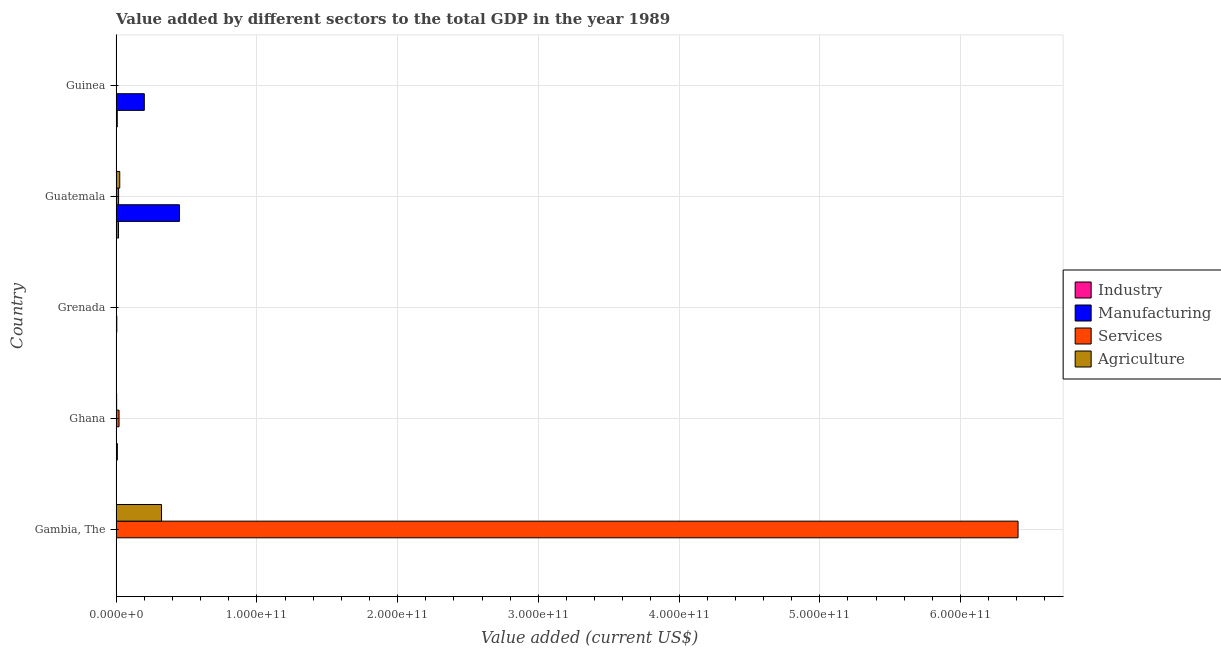How many different coloured bars are there?
Offer a terse response. 4. How many groups of bars are there?
Keep it short and to the point. 5. Are the number of bars on each tick of the Y-axis equal?
Your answer should be compact. Yes. How many bars are there on the 1st tick from the top?
Offer a very short reply. 4. How many bars are there on the 5th tick from the bottom?
Your answer should be compact. 4. What is the label of the 2nd group of bars from the top?
Your response must be concise. Guatemala. What is the value added by industrial sector in Ghana?
Offer a terse response. 8.78e+08. Across all countries, what is the maximum value added by manufacturing sector?
Provide a short and direct response. 4.50e+1. Across all countries, what is the minimum value added by agricultural sector?
Your answer should be very brief. 2.63e+07. In which country was the value added by services sector maximum?
Your answer should be very brief. Gambia, The. In which country was the value added by services sector minimum?
Offer a very short reply. Guinea. What is the total value added by manufacturing sector in the graph?
Make the answer very short. 6.55e+1. What is the difference between the value added by manufacturing sector in Ghana and that in Guatemala?
Your answer should be very brief. -4.49e+1. What is the difference between the value added by agricultural sector in Grenada and the value added by manufacturing sector in Ghana?
Offer a terse response. 2.91e+07. What is the average value added by manufacturing sector per country?
Provide a short and direct response. 1.31e+1. What is the difference between the value added by industrial sector and value added by services sector in Gambia, The?
Provide a succinct answer. -6.41e+11. What is the ratio of the value added by industrial sector in Ghana to that in Grenada?
Offer a very short reply. 28.63. Is the value added by industrial sector in Gambia, The less than that in Ghana?
Your answer should be very brief. Yes. What is the difference between the highest and the second highest value added by services sector?
Provide a succinct answer. 6.39e+11. What is the difference between the highest and the lowest value added by industrial sector?
Your answer should be very brief. 1.66e+09. Is the sum of the value added by services sector in Gambia, The and Guatemala greater than the maximum value added by agricultural sector across all countries?
Offer a very short reply. Yes. Is it the case that in every country, the sum of the value added by industrial sector and value added by services sector is greater than the sum of value added by manufacturing sector and value added by agricultural sector?
Provide a succinct answer. No. What does the 2nd bar from the top in Guinea represents?
Provide a short and direct response. Services. What does the 3rd bar from the bottom in Gambia, The represents?
Ensure brevity in your answer.  Services. Is it the case that in every country, the sum of the value added by industrial sector and value added by manufacturing sector is greater than the value added by services sector?
Keep it short and to the point. No. Are all the bars in the graph horizontal?
Your answer should be compact. Yes. What is the difference between two consecutive major ticks on the X-axis?
Make the answer very short. 1.00e+11. Are the values on the major ticks of X-axis written in scientific E-notation?
Your answer should be compact. Yes. Does the graph contain any zero values?
Offer a very short reply. No. Does the graph contain grids?
Your answer should be compact. Yes. Where does the legend appear in the graph?
Make the answer very short. Center right. How many legend labels are there?
Keep it short and to the point. 4. What is the title of the graph?
Your response must be concise. Value added by different sectors to the total GDP in the year 1989. Does "Miscellaneous expenses" appear as one of the legend labels in the graph?
Ensure brevity in your answer.  No. What is the label or title of the X-axis?
Ensure brevity in your answer.  Value added (current US$). What is the label or title of the Y-axis?
Offer a terse response. Country. What is the Value added (current US$) of Industry in Gambia, The?
Provide a succinct answer. 2.94e+07. What is the Value added (current US$) of Manufacturing in Gambia, The?
Provide a short and direct response. 1.57e+07. What is the Value added (current US$) of Services in Gambia, The?
Your answer should be very brief. 6.41e+11. What is the Value added (current US$) of Agriculture in Gambia, The?
Your response must be concise. 3.23e+1. What is the Value added (current US$) of Industry in Ghana?
Give a very brief answer. 8.78e+08. What is the Value added (current US$) in Manufacturing in Ghana?
Offer a very short reply. 4.45e+07. What is the Value added (current US$) in Services in Ghana?
Your response must be concise. 2.08e+09. What is the Value added (current US$) in Agriculture in Ghana?
Provide a short and direct response. 3.64e+08. What is the Value added (current US$) in Industry in Grenada?
Give a very brief answer. 3.07e+07. What is the Value added (current US$) of Manufacturing in Grenada?
Offer a terse response. 4.79e+08. What is the Value added (current US$) in Services in Grenada?
Ensure brevity in your answer.  1.81e+08. What is the Value added (current US$) of Agriculture in Grenada?
Provide a short and direct response. 7.36e+07. What is the Value added (current US$) in Industry in Guatemala?
Provide a short and direct response. 1.69e+09. What is the Value added (current US$) in Manufacturing in Guatemala?
Your answer should be very brief. 4.50e+1. What is the Value added (current US$) in Services in Guatemala?
Make the answer very short. 1.75e+09. What is the Value added (current US$) of Agriculture in Guatemala?
Your response must be concise. 2.57e+09. What is the Value added (current US$) in Industry in Guinea?
Make the answer very short. 8.07e+08. What is the Value added (current US$) in Manufacturing in Guinea?
Provide a short and direct response. 2.00e+1. What is the Value added (current US$) of Services in Guinea?
Offer a very short reply. 1.13e+08. What is the Value added (current US$) of Agriculture in Guinea?
Provide a short and direct response. 2.63e+07. Across all countries, what is the maximum Value added (current US$) in Industry?
Offer a very short reply. 1.69e+09. Across all countries, what is the maximum Value added (current US$) in Manufacturing?
Provide a short and direct response. 4.50e+1. Across all countries, what is the maximum Value added (current US$) in Services?
Offer a terse response. 6.41e+11. Across all countries, what is the maximum Value added (current US$) in Agriculture?
Offer a very short reply. 3.23e+1. Across all countries, what is the minimum Value added (current US$) of Industry?
Offer a terse response. 2.94e+07. Across all countries, what is the minimum Value added (current US$) of Manufacturing?
Offer a very short reply. 1.57e+07. Across all countries, what is the minimum Value added (current US$) in Services?
Give a very brief answer. 1.13e+08. Across all countries, what is the minimum Value added (current US$) of Agriculture?
Provide a short and direct response. 2.63e+07. What is the total Value added (current US$) of Industry in the graph?
Make the answer very short. 3.44e+09. What is the total Value added (current US$) in Manufacturing in the graph?
Provide a short and direct response. 6.55e+1. What is the total Value added (current US$) of Services in the graph?
Offer a very short reply. 6.45e+11. What is the total Value added (current US$) in Agriculture in the graph?
Your answer should be compact. 3.53e+1. What is the difference between the Value added (current US$) in Industry in Gambia, The and that in Ghana?
Your response must be concise. -8.49e+08. What is the difference between the Value added (current US$) in Manufacturing in Gambia, The and that in Ghana?
Provide a succinct answer. -2.88e+07. What is the difference between the Value added (current US$) in Services in Gambia, The and that in Ghana?
Your answer should be very brief. 6.39e+11. What is the difference between the Value added (current US$) of Agriculture in Gambia, The and that in Ghana?
Your response must be concise. 3.19e+1. What is the difference between the Value added (current US$) in Industry in Gambia, The and that in Grenada?
Provide a short and direct response. -1.27e+06. What is the difference between the Value added (current US$) in Manufacturing in Gambia, The and that in Grenada?
Offer a terse response. -4.63e+08. What is the difference between the Value added (current US$) of Services in Gambia, The and that in Grenada?
Offer a very short reply. 6.41e+11. What is the difference between the Value added (current US$) in Agriculture in Gambia, The and that in Grenada?
Your answer should be very brief. 3.22e+1. What is the difference between the Value added (current US$) of Industry in Gambia, The and that in Guatemala?
Provide a succinct answer. -1.66e+09. What is the difference between the Value added (current US$) in Manufacturing in Gambia, The and that in Guatemala?
Your answer should be compact. -4.50e+1. What is the difference between the Value added (current US$) in Services in Gambia, The and that in Guatemala?
Your response must be concise. 6.39e+11. What is the difference between the Value added (current US$) of Agriculture in Gambia, The and that in Guatemala?
Keep it short and to the point. 2.97e+1. What is the difference between the Value added (current US$) in Industry in Gambia, The and that in Guinea?
Your answer should be compact. -7.78e+08. What is the difference between the Value added (current US$) of Manufacturing in Gambia, The and that in Guinea?
Offer a very short reply. -2.00e+1. What is the difference between the Value added (current US$) of Services in Gambia, The and that in Guinea?
Keep it short and to the point. 6.41e+11. What is the difference between the Value added (current US$) of Agriculture in Gambia, The and that in Guinea?
Your response must be concise. 3.22e+1. What is the difference between the Value added (current US$) of Industry in Ghana and that in Grenada?
Provide a short and direct response. 8.48e+08. What is the difference between the Value added (current US$) in Manufacturing in Ghana and that in Grenada?
Keep it short and to the point. -4.34e+08. What is the difference between the Value added (current US$) of Services in Ghana and that in Grenada?
Offer a terse response. 1.89e+09. What is the difference between the Value added (current US$) in Agriculture in Ghana and that in Grenada?
Make the answer very short. 2.90e+08. What is the difference between the Value added (current US$) of Industry in Ghana and that in Guatemala?
Ensure brevity in your answer.  -8.13e+08. What is the difference between the Value added (current US$) in Manufacturing in Ghana and that in Guatemala?
Provide a short and direct response. -4.49e+1. What is the difference between the Value added (current US$) of Services in Ghana and that in Guatemala?
Give a very brief answer. 3.22e+08. What is the difference between the Value added (current US$) in Agriculture in Ghana and that in Guatemala?
Offer a very short reply. -2.21e+09. What is the difference between the Value added (current US$) in Industry in Ghana and that in Guinea?
Offer a very short reply. 7.11e+07. What is the difference between the Value added (current US$) in Manufacturing in Ghana and that in Guinea?
Offer a very short reply. -2.00e+1. What is the difference between the Value added (current US$) of Services in Ghana and that in Guinea?
Your answer should be compact. 1.96e+09. What is the difference between the Value added (current US$) in Agriculture in Ghana and that in Guinea?
Ensure brevity in your answer.  3.37e+08. What is the difference between the Value added (current US$) in Industry in Grenada and that in Guatemala?
Make the answer very short. -1.66e+09. What is the difference between the Value added (current US$) in Manufacturing in Grenada and that in Guatemala?
Offer a terse response. -4.45e+1. What is the difference between the Value added (current US$) of Services in Grenada and that in Guatemala?
Make the answer very short. -1.57e+09. What is the difference between the Value added (current US$) of Agriculture in Grenada and that in Guatemala?
Your response must be concise. -2.50e+09. What is the difference between the Value added (current US$) of Industry in Grenada and that in Guinea?
Ensure brevity in your answer.  -7.77e+08. What is the difference between the Value added (current US$) of Manufacturing in Grenada and that in Guinea?
Your response must be concise. -1.95e+1. What is the difference between the Value added (current US$) of Services in Grenada and that in Guinea?
Offer a very short reply. 6.76e+07. What is the difference between the Value added (current US$) in Agriculture in Grenada and that in Guinea?
Provide a short and direct response. 4.73e+07. What is the difference between the Value added (current US$) in Industry in Guatemala and that in Guinea?
Your answer should be compact. 8.84e+08. What is the difference between the Value added (current US$) in Manufacturing in Guatemala and that in Guinea?
Your answer should be very brief. 2.49e+1. What is the difference between the Value added (current US$) of Services in Guatemala and that in Guinea?
Keep it short and to the point. 1.64e+09. What is the difference between the Value added (current US$) in Agriculture in Guatemala and that in Guinea?
Your response must be concise. 2.55e+09. What is the difference between the Value added (current US$) of Industry in Gambia, The and the Value added (current US$) of Manufacturing in Ghana?
Your answer should be compact. -1.51e+07. What is the difference between the Value added (current US$) in Industry in Gambia, The and the Value added (current US$) in Services in Ghana?
Offer a very short reply. -2.05e+09. What is the difference between the Value added (current US$) of Industry in Gambia, The and the Value added (current US$) of Agriculture in Ghana?
Your response must be concise. -3.34e+08. What is the difference between the Value added (current US$) in Manufacturing in Gambia, The and the Value added (current US$) in Services in Ghana?
Make the answer very short. -2.06e+09. What is the difference between the Value added (current US$) of Manufacturing in Gambia, The and the Value added (current US$) of Agriculture in Ghana?
Offer a terse response. -3.48e+08. What is the difference between the Value added (current US$) of Services in Gambia, The and the Value added (current US$) of Agriculture in Ghana?
Offer a terse response. 6.40e+11. What is the difference between the Value added (current US$) of Industry in Gambia, The and the Value added (current US$) of Manufacturing in Grenada?
Keep it short and to the point. -4.50e+08. What is the difference between the Value added (current US$) in Industry in Gambia, The and the Value added (current US$) in Services in Grenada?
Keep it short and to the point. -1.52e+08. What is the difference between the Value added (current US$) in Industry in Gambia, The and the Value added (current US$) in Agriculture in Grenada?
Provide a short and direct response. -4.42e+07. What is the difference between the Value added (current US$) in Manufacturing in Gambia, The and the Value added (current US$) in Services in Grenada?
Ensure brevity in your answer.  -1.65e+08. What is the difference between the Value added (current US$) of Manufacturing in Gambia, The and the Value added (current US$) of Agriculture in Grenada?
Keep it short and to the point. -5.79e+07. What is the difference between the Value added (current US$) of Services in Gambia, The and the Value added (current US$) of Agriculture in Grenada?
Keep it short and to the point. 6.41e+11. What is the difference between the Value added (current US$) of Industry in Gambia, The and the Value added (current US$) of Manufacturing in Guatemala?
Your answer should be compact. -4.49e+1. What is the difference between the Value added (current US$) in Industry in Gambia, The and the Value added (current US$) in Services in Guatemala?
Offer a terse response. -1.72e+09. What is the difference between the Value added (current US$) in Industry in Gambia, The and the Value added (current US$) in Agriculture in Guatemala?
Provide a short and direct response. -2.54e+09. What is the difference between the Value added (current US$) in Manufacturing in Gambia, The and the Value added (current US$) in Services in Guatemala?
Your answer should be very brief. -1.74e+09. What is the difference between the Value added (current US$) of Manufacturing in Gambia, The and the Value added (current US$) of Agriculture in Guatemala?
Your response must be concise. -2.56e+09. What is the difference between the Value added (current US$) of Services in Gambia, The and the Value added (current US$) of Agriculture in Guatemala?
Your answer should be compact. 6.38e+11. What is the difference between the Value added (current US$) in Industry in Gambia, The and the Value added (current US$) in Manufacturing in Guinea?
Provide a short and direct response. -2.00e+1. What is the difference between the Value added (current US$) of Industry in Gambia, The and the Value added (current US$) of Services in Guinea?
Make the answer very short. -8.40e+07. What is the difference between the Value added (current US$) of Industry in Gambia, The and the Value added (current US$) of Agriculture in Guinea?
Your response must be concise. 3.08e+06. What is the difference between the Value added (current US$) of Manufacturing in Gambia, The and the Value added (current US$) of Services in Guinea?
Offer a very short reply. -9.77e+07. What is the difference between the Value added (current US$) of Manufacturing in Gambia, The and the Value added (current US$) of Agriculture in Guinea?
Offer a very short reply. -1.06e+07. What is the difference between the Value added (current US$) of Services in Gambia, The and the Value added (current US$) of Agriculture in Guinea?
Make the answer very short. 6.41e+11. What is the difference between the Value added (current US$) in Industry in Ghana and the Value added (current US$) in Manufacturing in Grenada?
Make the answer very short. 3.99e+08. What is the difference between the Value added (current US$) of Industry in Ghana and the Value added (current US$) of Services in Grenada?
Ensure brevity in your answer.  6.97e+08. What is the difference between the Value added (current US$) of Industry in Ghana and the Value added (current US$) of Agriculture in Grenada?
Keep it short and to the point. 8.05e+08. What is the difference between the Value added (current US$) in Manufacturing in Ghana and the Value added (current US$) in Services in Grenada?
Your answer should be compact. -1.37e+08. What is the difference between the Value added (current US$) of Manufacturing in Ghana and the Value added (current US$) of Agriculture in Grenada?
Offer a terse response. -2.91e+07. What is the difference between the Value added (current US$) of Services in Ghana and the Value added (current US$) of Agriculture in Grenada?
Your response must be concise. 2.00e+09. What is the difference between the Value added (current US$) in Industry in Ghana and the Value added (current US$) in Manufacturing in Guatemala?
Give a very brief answer. -4.41e+1. What is the difference between the Value added (current US$) in Industry in Ghana and the Value added (current US$) in Services in Guatemala?
Your answer should be very brief. -8.76e+08. What is the difference between the Value added (current US$) of Industry in Ghana and the Value added (current US$) of Agriculture in Guatemala?
Ensure brevity in your answer.  -1.69e+09. What is the difference between the Value added (current US$) in Manufacturing in Ghana and the Value added (current US$) in Services in Guatemala?
Offer a terse response. -1.71e+09. What is the difference between the Value added (current US$) in Manufacturing in Ghana and the Value added (current US$) in Agriculture in Guatemala?
Your response must be concise. -2.53e+09. What is the difference between the Value added (current US$) of Services in Ghana and the Value added (current US$) of Agriculture in Guatemala?
Provide a succinct answer. -4.96e+08. What is the difference between the Value added (current US$) in Industry in Ghana and the Value added (current US$) in Manufacturing in Guinea?
Offer a terse response. -1.91e+1. What is the difference between the Value added (current US$) of Industry in Ghana and the Value added (current US$) of Services in Guinea?
Keep it short and to the point. 7.65e+08. What is the difference between the Value added (current US$) in Industry in Ghana and the Value added (current US$) in Agriculture in Guinea?
Provide a short and direct response. 8.52e+08. What is the difference between the Value added (current US$) in Manufacturing in Ghana and the Value added (current US$) in Services in Guinea?
Ensure brevity in your answer.  -6.89e+07. What is the difference between the Value added (current US$) of Manufacturing in Ghana and the Value added (current US$) of Agriculture in Guinea?
Your answer should be compact. 1.82e+07. What is the difference between the Value added (current US$) in Services in Ghana and the Value added (current US$) in Agriculture in Guinea?
Keep it short and to the point. 2.05e+09. What is the difference between the Value added (current US$) of Industry in Grenada and the Value added (current US$) of Manufacturing in Guatemala?
Your response must be concise. -4.49e+1. What is the difference between the Value added (current US$) of Industry in Grenada and the Value added (current US$) of Services in Guatemala?
Keep it short and to the point. -1.72e+09. What is the difference between the Value added (current US$) in Industry in Grenada and the Value added (current US$) in Agriculture in Guatemala?
Provide a short and direct response. -2.54e+09. What is the difference between the Value added (current US$) of Manufacturing in Grenada and the Value added (current US$) of Services in Guatemala?
Provide a succinct answer. -1.27e+09. What is the difference between the Value added (current US$) in Manufacturing in Grenada and the Value added (current US$) in Agriculture in Guatemala?
Offer a terse response. -2.09e+09. What is the difference between the Value added (current US$) of Services in Grenada and the Value added (current US$) of Agriculture in Guatemala?
Provide a short and direct response. -2.39e+09. What is the difference between the Value added (current US$) of Industry in Grenada and the Value added (current US$) of Manufacturing in Guinea?
Make the answer very short. -2.00e+1. What is the difference between the Value added (current US$) of Industry in Grenada and the Value added (current US$) of Services in Guinea?
Provide a short and direct response. -8.28e+07. What is the difference between the Value added (current US$) of Industry in Grenada and the Value added (current US$) of Agriculture in Guinea?
Provide a short and direct response. 4.34e+06. What is the difference between the Value added (current US$) of Manufacturing in Grenada and the Value added (current US$) of Services in Guinea?
Offer a very short reply. 3.66e+08. What is the difference between the Value added (current US$) in Manufacturing in Grenada and the Value added (current US$) in Agriculture in Guinea?
Your response must be concise. 4.53e+08. What is the difference between the Value added (current US$) of Services in Grenada and the Value added (current US$) of Agriculture in Guinea?
Make the answer very short. 1.55e+08. What is the difference between the Value added (current US$) in Industry in Guatemala and the Value added (current US$) in Manufacturing in Guinea?
Your response must be concise. -1.83e+1. What is the difference between the Value added (current US$) in Industry in Guatemala and the Value added (current US$) in Services in Guinea?
Your response must be concise. 1.58e+09. What is the difference between the Value added (current US$) of Industry in Guatemala and the Value added (current US$) of Agriculture in Guinea?
Provide a succinct answer. 1.66e+09. What is the difference between the Value added (current US$) in Manufacturing in Guatemala and the Value added (current US$) in Services in Guinea?
Ensure brevity in your answer.  4.49e+1. What is the difference between the Value added (current US$) of Manufacturing in Guatemala and the Value added (current US$) of Agriculture in Guinea?
Ensure brevity in your answer.  4.49e+1. What is the difference between the Value added (current US$) of Services in Guatemala and the Value added (current US$) of Agriculture in Guinea?
Provide a succinct answer. 1.73e+09. What is the average Value added (current US$) in Industry per country?
Make the answer very short. 6.87e+08. What is the average Value added (current US$) in Manufacturing per country?
Keep it short and to the point. 1.31e+1. What is the average Value added (current US$) of Services per country?
Offer a very short reply. 1.29e+11. What is the average Value added (current US$) of Agriculture per country?
Provide a short and direct response. 7.06e+09. What is the difference between the Value added (current US$) of Industry and Value added (current US$) of Manufacturing in Gambia, The?
Provide a succinct answer. 1.37e+07. What is the difference between the Value added (current US$) of Industry and Value added (current US$) of Services in Gambia, The?
Keep it short and to the point. -6.41e+11. What is the difference between the Value added (current US$) in Industry and Value added (current US$) in Agriculture in Gambia, The?
Provide a short and direct response. -3.22e+1. What is the difference between the Value added (current US$) in Manufacturing and Value added (current US$) in Services in Gambia, The?
Keep it short and to the point. -6.41e+11. What is the difference between the Value added (current US$) of Manufacturing and Value added (current US$) of Agriculture in Gambia, The?
Your answer should be very brief. -3.22e+1. What is the difference between the Value added (current US$) in Services and Value added (current US$) in Agriculture in Gambia, The?
Make the answer very short. 6.09e+11. What is the difference between the Value added (current US$) in Industry and Value added (current US$) in Manufacturing in Ghana?
Your answer should be very brief. 8.34e+08. What is the difference between the Value added (current US$) in Industry and Value added (current US$) in Services in Ghana?
Your response must be concise. -1.20e+09. What is the difference between the Value added (current US$) of Industry and Value added (current US$) of Agriculture in Ghana?
Your answer should be compact. 5.15e+08. What is the difference between the Value added (current US$) in Manufacturing and Value added (current US$) in Services in Ghana?
Your answer should be compact. -2.03e+09. What is the difference between the Value added (current US$) in Manufacturing and Value added (current US$) in Agriculture in Ghana?
Ensure brevity in your answer.  -3.19e+08. What is the difference between the Value added (current US$) of Services and Value added (current US$) of Agriculture in Ghana?
Make the answer very short. 1.71e+09. What is the difference between the Value added (current US$) of Industry and Value added (current US$) of Manufacturing in Grenada?
Your answer should be compact. -4.48e+08. What is the difference between the Value added (current US$) of Industry and Value added (current US$) of Services in Grenada?
Provide a short and direct response. -1.50e+08. What is the difference between the Value added (current US$) in Industry and Value added (current US$) in Agriculture in Grenada?
Your answer should be compact. -4.30e+07. What is the difference between the Value added (current US$) in Manufacturing and Value added (current US$) in Services in Grenada?
Make the answer very short. 2.98e+08. What is the difference between the Value added (current US$) in Manufacturing and Value added (current US$) in Agriculture in Grenada?
Make the answer very short. 4.05e+08. What is the difference between the Value added (current US$) in Services and Value added (current US$) in Agriculture in Grenada?
Your answer should be compact. 1.07e+08. What is the difference between the Value added (current US$) in Industry and Value added (current US$) in Manufacturing in Guatemala?
Make the answer very short. -4.33e+1. What is the difference between the Value added (current US$) of Industry and Value added (current US$) of Services in Guatemala?
Offer a terse response. -6.28e+07. What is the difference between the Value added (current US$) of Industry and Value added (current US$) of Agriculture in Guatemala?
Provide a short and direct response. -8.81e+08. What is the difference between the Value added (current US$) of Manufacturing and Value added (current US$) of Services in Guatemala?
Give a very brief answer. 4.32e+1. What is the difference between the Value added (current US$) of Manufacturing and Value added (current US$) of Agriculture in Guatemala?
Provide a succinct answer. 4.24e+1. What is the difference between the Value added (current US$) in Services and Value added (current US$) in Agriculture in Guatemala?
Offer a very short reply. -8.18e+08. What is the difference between the Value added (current US$) in Industry and Value added (current US$) in Manufacturing in Guinea?
Your answer should be very brief. -1.92e+1. What is the difference between the Value added (current US$) of Industry and Value added (current US$) of Services in Guinea?
Provide a succinct answer. 6.94e+08. What is the difference between the Value added (current US$) in Industry and Value added (current US$) in Agriculture in Guinea?
Keep it short and to the point. 7.81e+08. What is the difference between the Value added (current US$) in Manufacturing and Value added (current US$) in Services in Guinea?
Provide a short and direct response. 1.99e+1. What is the difference between the Value added (current US$) in Manufacturing and Value added (current US$) in Agriculture in Guinea?
Keep it short and to the point. 2.00e+1. What is the difference between the Value added (current US$) in Services and Value added (current US$) in Agriculture in Guinea?
Provide a succinct answer. 8.71e+07. What is the ratio of the Value added (current US$) in Industry in Gambia, The to that in Ghana?
Your answer should be very brief. 0.03. What is the ratio of the Value added (current US$) of Manufacturing in Gambia, The to that in Ghana?
Ensure brevity in your answer.  0.35. What is the ratio of the Value added (current US$) in Services in Gambia, The to that in Ghana?
Your answer should be very brief. 308.73. What is the ratio of the Value added (current US$) in Agriculture in Gambia, The to that in Ghana?
Offer a very short reply. 88.73. What is the ratio of the Value added (current US$) of Industry in Gambia, The to that in Grenada?
Provide a succinct answer. 0.96. What is the ratio of the Value added (current US$) of Manufacturing in Gambia, The to that in Grenada?
Your response must be concise. 0.03. What is the ratio of the Value added (current US$) in Services in Gambia, The to that in Grenada?
Ensure brevity in your answer.  3539.2. What is the ratio of the Value added (current US$) of Agriculture in Gambia, The to that in Grenada?
Give a very brief answer. 438.18. What is the ratio of the Value added (current US$) in Industry in Gambia, The to that in Guatemala?
Keep it short and to the point. 0.02. What is the ratio of the Value added (current US$) of Services in Gambia, The to that in Guatemala?
Your answer should be compact. 365.41. What is the ratio of the Value added (current US$) of Agriculture in Gambia, The to that in Guatemala?
Your response must be concise. 12.55. What is the ratio of the Value added (current US$) in Industry in Gambia, The to that in Guinea?
Give a very brief answer. 0.04. What is the ratio of the Value added (current US$) of Manufacturing in Gambia, The to that in Guinea?
Give a very brief answer. 0. What is the ratio of the Value added (current US$) in Services in Gambia, The to that in Guinea?
Offer a very short reply. 5648.57. What is the ratio of the Value added (current US$) in Agriculture in Gambia, The to that in Guinea?
Offer a terse response. 1225.04. What is the ratio of the Value added (current US$) in Industry in Ghana to that in Grenada?
Your answer should be compact. 28.63. What is the ratio of the Value added (current US$) of Manufacturing in Ghana to that in Grenada?
Provide a succinct answer. 0.09. What is the ratio of the Value added (current US$) of Services in Ghana to that in Grenada?
Offer a very short reply. 11.46. What is the ratio of the Value added (current US$) in Agriculture in Ghana to that in Grenada?
Give a very brief answer. 4.94. What is the ratio of the Value added (current US$) of Industry in Ghana to that in Guatemala?
Your answer should be very brief. 0.52. What is the ratio of the Value added (current US$) of Services in Ghana to that in Guatemala?
Offer a terse response. 1.18. What is the ratio of the Value added (current US$) in Agriculture in Ghana to that in Guatemala?
Offer a terse response. 0.14. What is the ratio of the Value added (current US$) in Industry in Ghana to that in Guinea?
Your response must be concise. 1.09. What is the ratio of the Value added (current US$) in Manufacturing in Ghana to that in Guinea?
Ensure brevity in your answer.  0. What is the ratio of the Value added (current US$) in Services in Ghana to that in Guinea?
Provide a short and direct response. 18.3. What is the ratio of the Value added (current US$) in Agriculture in Ghana to that in Guinea?
Offer a very short reply. 13.81. What is the ratio of the Value added (current US$) of Industry in Grenada to that in Guatemala?
Your answer should be very brief. 0.02. What is the ratio of the Value added (current US$) in Manufacturing in Grenada to that in Guatemala?
Offer a very short reply. 0.01. What is the ratio of the Value added (current US$) in Services in Grenada to that in Guatemala?
Ensure brevity in your answer.  0.1. What is the ratio of the Value added (current US$) in Agriculture in Grenada to that in Guatemala?
Your answer should be compact. 0.03. What is the ratio of the Value added (current US$) in Industry in Grenada to that in Guinea?
Ensure brevity in your answer.  0.04. What is the ratio of the Value added (current US$) of Manufacturing in Grenada to that in Guinea?
Provide a succinct answer. 0.02. What is the ratio of the Value added (current US$) in Services in Grenada to that in Guinea?
Offer a terse response. 1.6. What is the ratio of the Value added (current US$) of Agriculture in Grenada to that in Guinea?
Ensure brevity in your answer.  2.8. What is the ratio of the Value added (current US$) in Industry in Guatemala to that in Guinea?
Offer a very short reply. 2.09. What is the ratio of the Value added (current US$) in Manufacturing in Guatemala to that in Guinea?
Ensure brevity in your answer.  2.25. What is the ratio of the Value added (current US$) of Services in Guatemala to that in Guinea?
Ensure brevity in your answer.  15.46. What is the ratio of the Value added (current US$) in Agriculture in Guatemala to that in Guinea?
Provide a short and direct response. 97.64. What is the difference between the highest and the second highest Value added (current US$) in Industry?
Provide a succinct answer. 8.13e+08. What is the difference between the highest and the second highest Value added (current US$) of Manufacturing?
Ensure brevity in your answer.  2.49e+1. What is the difference between the highest and the second highest Value added (current US$) of Services?
Ensure brevity in your answer.  6.39e+11. What is the difference between the highest and the second highest Value added (current US$) in Agriculture?
Provide a short and direct response. 2.97e+1. What is the difference between the highest and the lowest Value added (current US$) of Industry?
Ensure brevity in your answer.  1.66e+09. What is the difference between the highest and the lowest Value added (current US$) in Manufacturing?
Provide a short and direct response. 4.50e+1. What is the difference between the highest and the lowest Value added (current US$) in Services?
Offer a very short reply. 6.41e+11. What is the difference between the highest and the lowest Value added (current US$) in Agriculture?
Provide a short and direct response. 3.22e+1. 